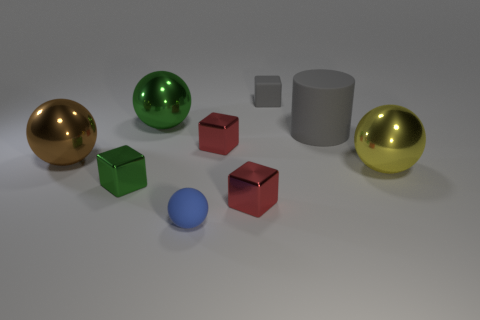The rubber object that is the same size as the yellow metal thing is what color?
Keep it short and to the point. Gray. What is the color of the big metal object that is behind the brown object?
Give a very brief answer. Green. Are there any tiny green cubes that are in front of the object behind the green shiny sphere?
Provide a succinct answer. Yes. Is the shape of the small blue matte object the same as the tiny red thing that is behind the yellow metal sphere?
Provide a succinct answer. No. There is a matte object that is left of the big gray cylinder and in front of the tiny gray object; what is its size?
Ensure brevity in your answer.  Small. Is there a tiny gray thing that has the same material as the big yellow sphere?
Your answer should be very brief. No. What size is the thing that is the same color as the matte cube?
Keep it short and to the point. Large. The large sphere to the right of the gray rubber object to the left of the gray cylinder is made of what material?
Offer a very short reply. Metal. How many small metal cubes have the same color as the cylinder?
Provide a succinct answer. 0. The other gray object that is made of the same material as the tiny gray thing is what size?
Keep it short and to the point. Large. 